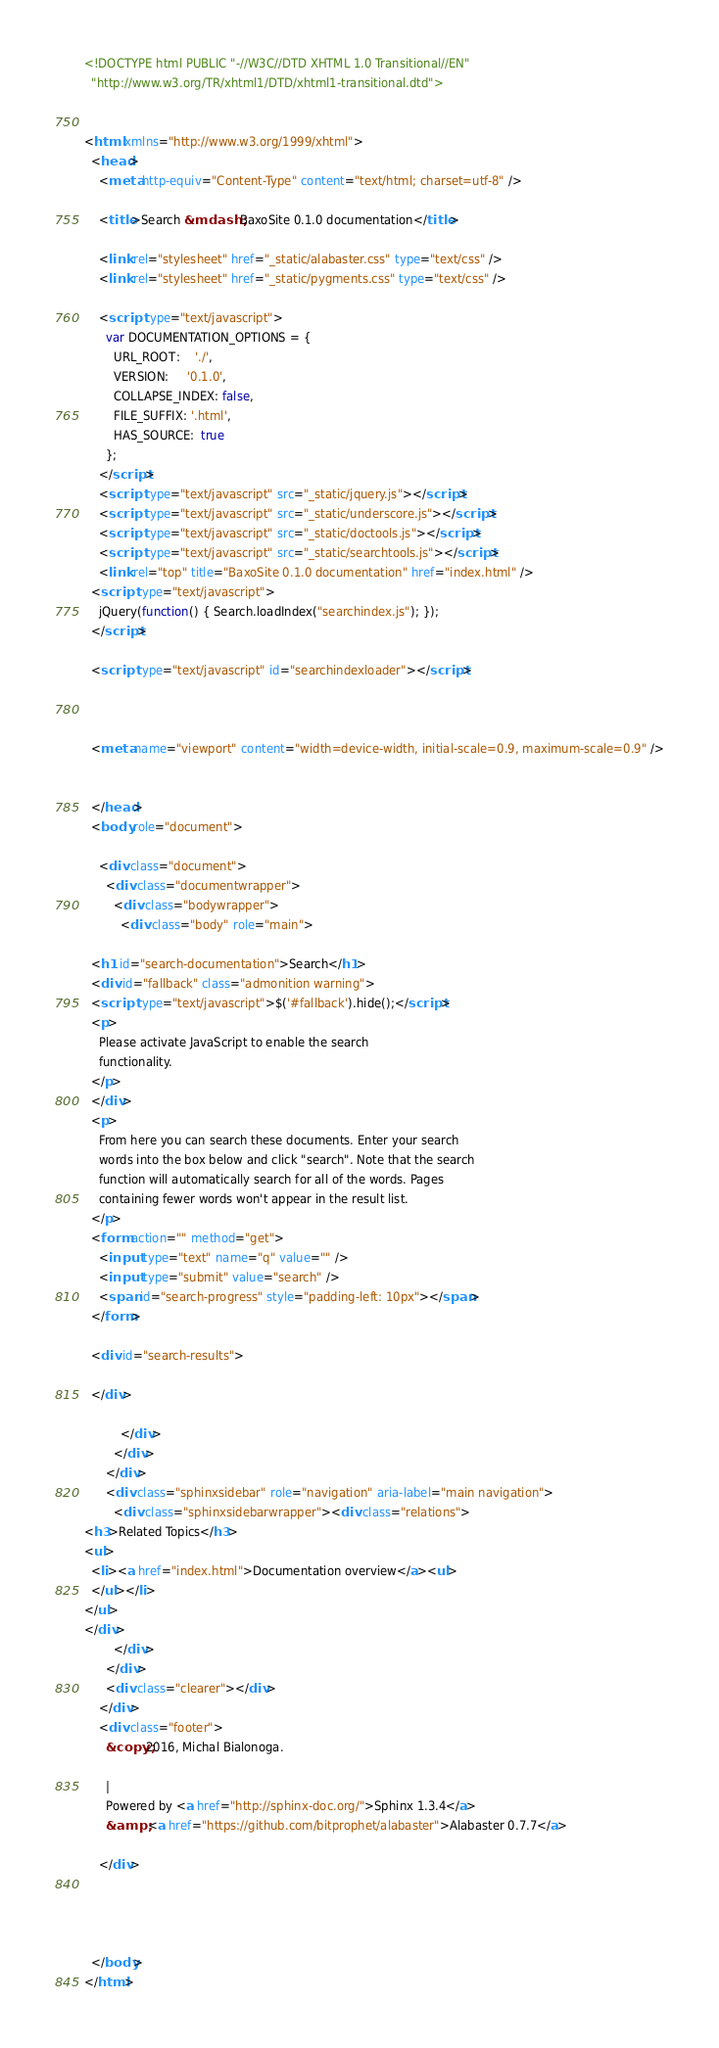<code> <loc_0><loc_0><loc_500><loc_500><_HTML_><!DOCTYPE html PUBLIC "-//W3C//DTD XHTML 1.0 Transitional//EN"
  "http://www.w3.org/TR/xhtml1/DTD/xhtml1-transitional.dtd">


<html xmlns="http://www.w3.org/1999/xhtml">
  <head>
    <meta http-equiv="Content-Type" content="text/html; charset=utf-8" />
    
    <title>Search &mdash; BaxoSite 0.1.0 documentation</title>
    
    <link rel="stylesheet" href="_static/alabaster.css" type="text/css" />
    <link rel="stylesheet" href="_static/pygments.css" type="text/css" />
    
    <script type="text/javascript">
      var DOCUMENTATION_OPTIONS = {
        URL_ROOT:    './',
        VERSION:     '0.1.0',
        COLLAPSE_INDEX: false,
        FILE_SUFFIX: '.html',
        HAS_SOURCE:  true
      };
    </script>
    <script type="text/javascript" src="_static/jquery.js"></script>
    <script type="text/javascript" src="_static/underscore.js"></script>
    <script type="text/javascript" src="_static/doctools.js"></script>
    <script type="text/javascript" src="_static/searchtools.js"></script>
    <link rel="top" title="BaxoSite 0.1.0 documentation" href="index.html" />
  <script type="text/javascript">
    jQuery(function() { Search.loadIndex("searchindex.js"); });
  </script>
  
  <script type="text/javascript" id="searchindexloader"></script>
  
   
  
  <meta name="viewport" content="width=device-width, initial-scale=0.9, maximum-scale=0.9" />


  </head>
  <body role="document">  

    <div class="document">
      <div class="documentwrapper">
        <div class="bodywrapper">
          <div class="body" role="main">
            
  <h1 id="search-documentation">Search</h1>
  <div id="fallback" class="admonition warning">
  <script type="text/javascript">$('#fallback').hide();</script>
  <p>
    Please activate JavaScript to enable the search
    functionality.
  </p>
  </div>
  <p>
    From here you can search these documents. Enter your search
    words into the box below and click "search". Note that the search
    function will automatically search for all of the words. Pages
    containing fewer words won't appear in the result list.
  </p>
  <form action="" method="get">
    <input type="text" name="q" value="" />
    <input type="submit" value="search" />
    <span id="search-progress" style="padding-left: 10px"></span>
  </form>
  
  <div id="search-results">
  
  </div>

          </div>
        </div>
      </div>
      <div class="sphinxsidebar" role="navigation" aria-label="main navigation">
        <div class="sphinxsidebarwrapper"><div class="relations">
<h3>Related Topics</h3>
<ul>
  <li><a href="index.html">Documentation overview</a><ul>
  </ul></li>
</ul>
</div>
        </div>
      </div>
      <div class="clearer"></div>
    </div>
    <div class="footer">
      &copy;2016, Michal Bialonoga.
      
      |
      Powered by <a href="http://sphinx-doc.org/">Sphinx 1.3.4</a>
      &amp; <a href="https://github.com/bitprophet/alabaster">Alabaster 0.7.7</a>
      
    </div>

    

    
  </body>
</html></code> 